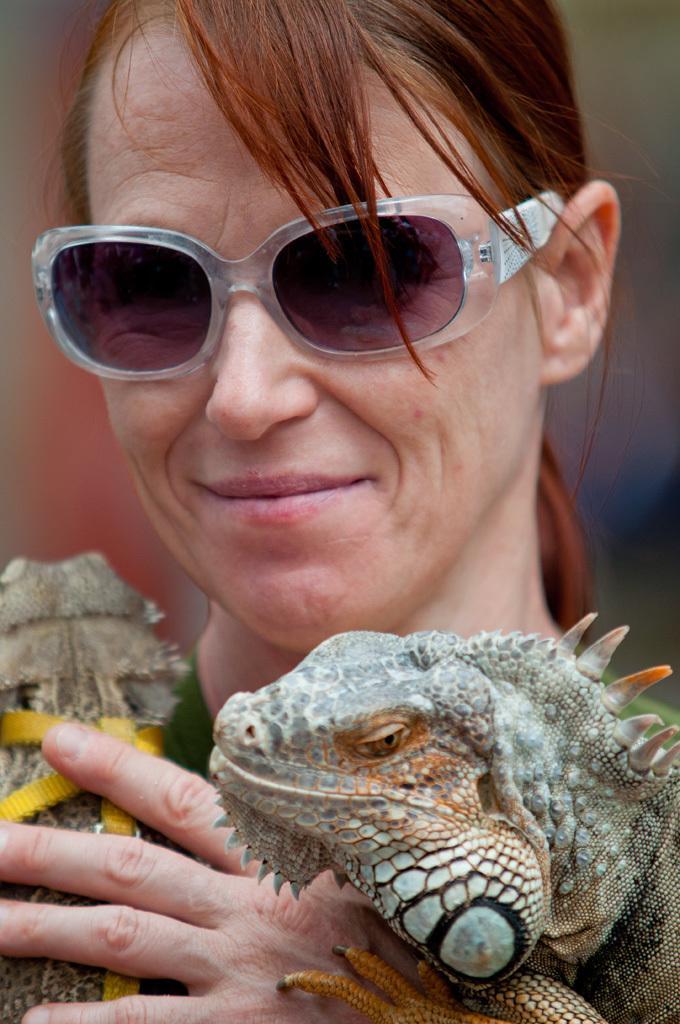Please provide a concise description of this image. In this image I can see the person wearing the goggles and holding the reptiles which are in brown and grey color. And there is a blurred background. 